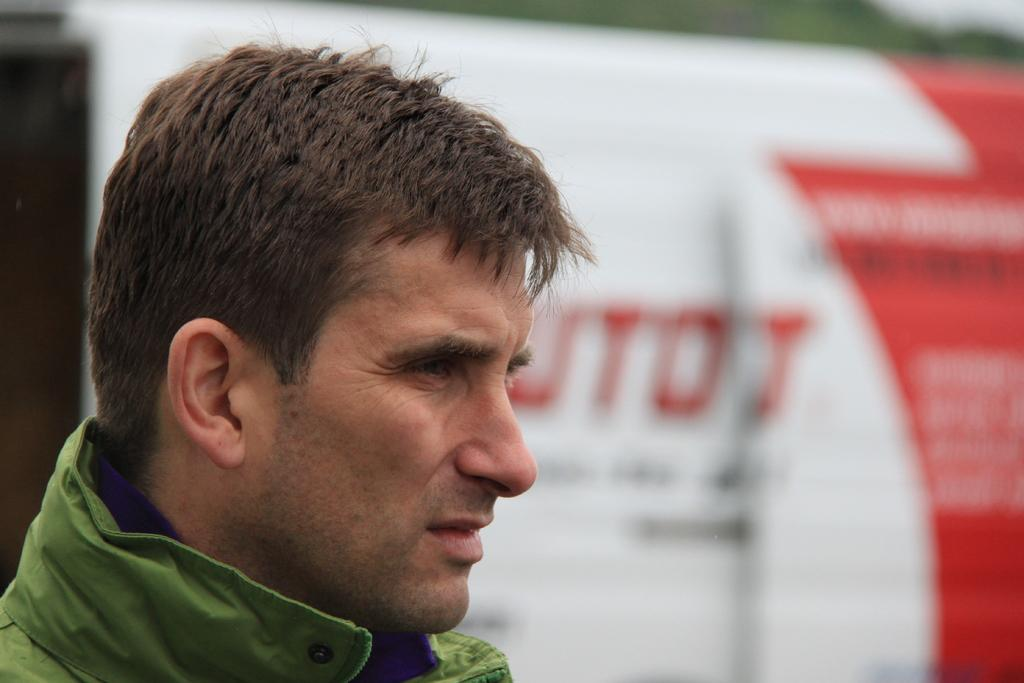Who is present in the image? There is a man in the image. Can you describe the background of the image? The background of the image is blurry. What can be seen in the background of the image? There is a hoarding in the background of the image. Where is the rock that the bird is sitting on in the image? There is no rock or bird present in the image; it features a man with a blurry background and a hoarding. What type of nest can be seen in the image? There is no nest present in the image. 